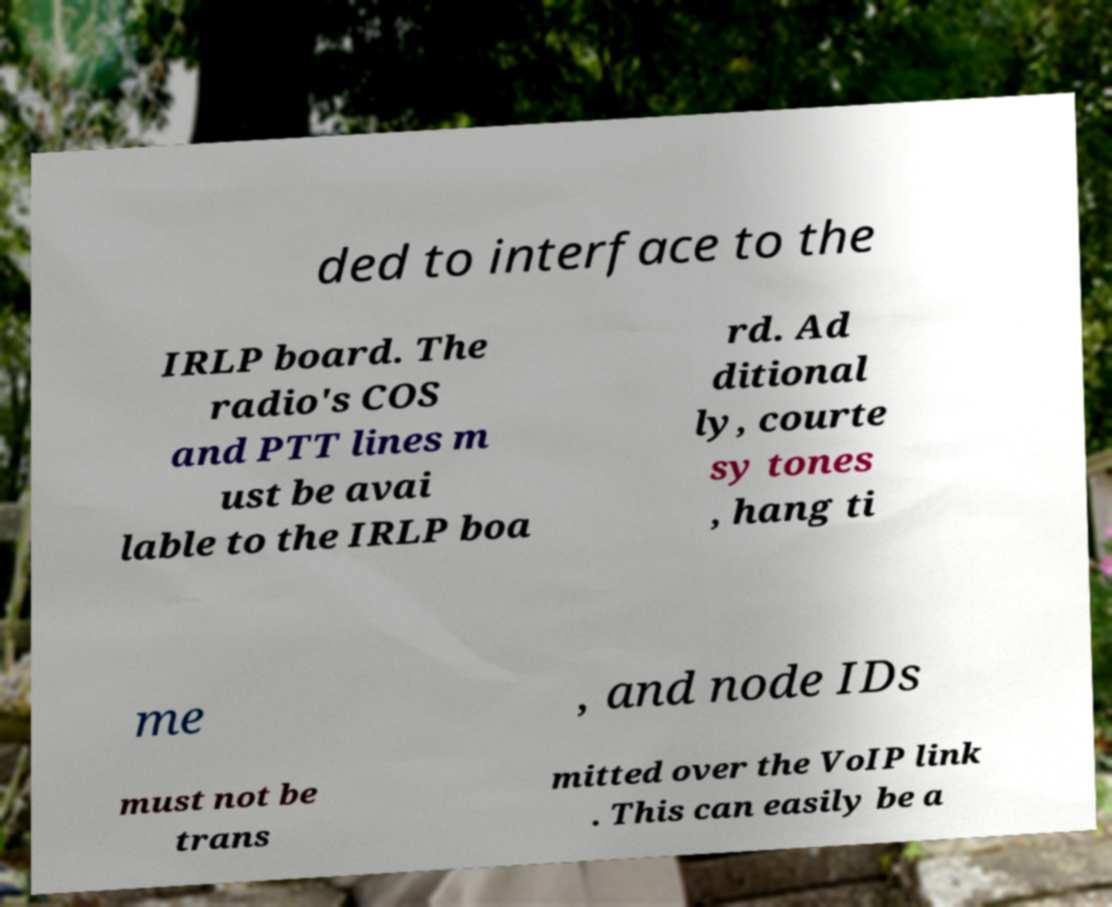Could you extract and type out the text from this image? ded to interface to the IRLP board. The radio's COS and PTT lines m ust be avai lable to the IRLP boa rd. Ad ditional ly, courte sy tones , hang ti me , and node IDs must not be trans mitted over the VoIP link . This can easily be a 